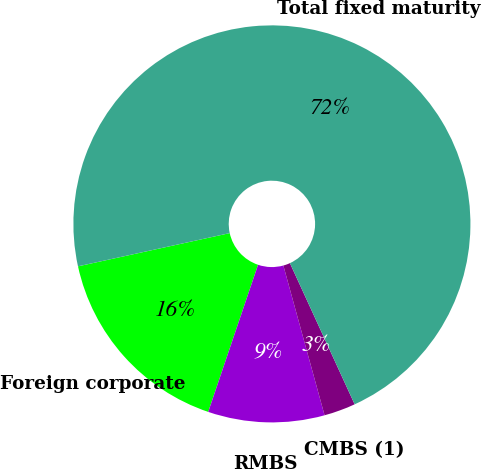Convert chart to OTSL. <chart><loc_0><loc_0><loc_500><loc_500><pie_chart><fcel>Foreign corporate<fcel>RMBS<fcel>CMBS (1)<fcel>Total fixed maturity<nl><fcel>16.37%<fcel>9.47%<fcel>2.57%<fcel>71.58%<nl></chart> 